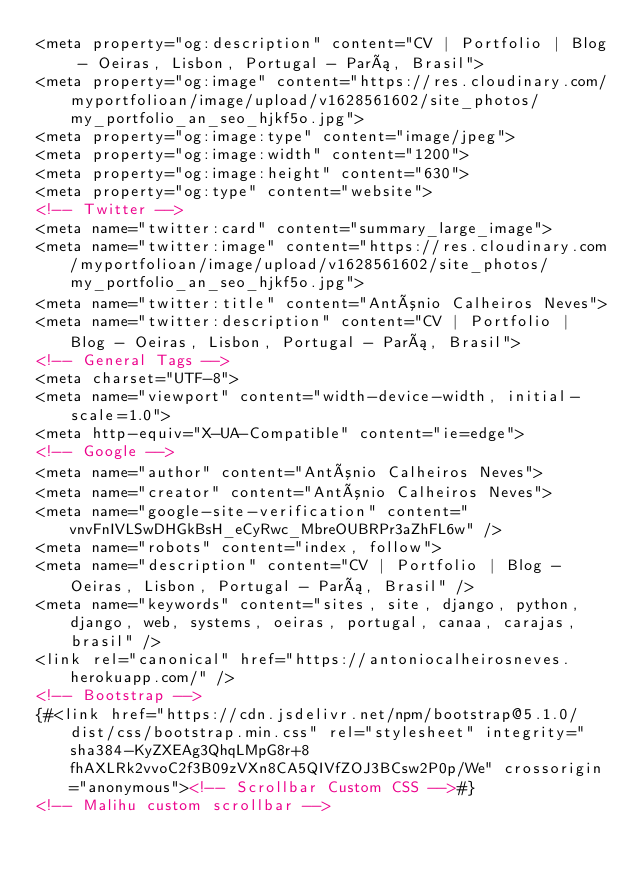Convert code to text. <code><loc_0><loc_0><loc_500><loc_500><_HTML_><meta property="og:description" content="CV | Portfolio | Blog - Oeiras, Lisbon, Portugal - Pará, Brasil">
<meta property="og:image" content="https://res.cloudinary.com/myportfolioan/image/upload/v1628561602/site_photos/my_portfolio_an_seo_hjkf5o.jpg">
<meta property="og:image:type" content="image/jpeg">
<meta property="og:image:width" content="1200">
<meta property="og:image:height" content="630">
<meta property="og:type" content="website">
<!-- Twitter -->
<meta name="twitter:card" content="summary_large_image">
<meta name="twitter:image" content="https://res.cloudinary.com/myportfolioan/image/upload/v1628561602/site_photos/my_portfolio_an_seo_hjkf5o.jpg">
<meta name="twitter:title" content="António Calheiros Neves">
<meta name="twitter:description" content="CV | Portfolio | Blog - Oeiras, Lisbon, Portugal - Pará, Brasil">
<!-- General Tags -->
<meta charset="UTF-8">
<meta name="viewport" content="width-device-width, initial-scale=1.0">
<meta http-equiv="X-UA-Compatible" content="ie=edge">
<!-- Google -->
<meta name="author" content="António Calheiros Neves">
<meta name="creator" content="António Calheiros Neves">
<meta name="google-site-verification" content="vnvFnIVLSwDHGkBsH_eCyRwc_MbreOUBRPr3aZhFL6w" />
<meta name="robots" content="index, follow">
<meta name="description" content="CV | Portfolio | Blog - Oeiras, Lisbon, Portugal - Pará, Brasil" />
<meta name="keywords" content="sites, site, django, python, django, web, systems, oeiras, portugal, canaa, carajas, brasil" />
<link rel="canonical" href="https://antoniocalheirosneves.herokuapp.com/" />
<!-- Bootstrap -->
{#<link href="https://cdn.jsdelivr.net/npm/bootstrap@5.1.0/dist/css/bootstrap.min.css" rel="stylesheet" integrity="sha384-KyZXEAg3QhqLMpG8r+8fhAXLRk2vvoC2f3B09zVXn8CA5QIVfZOJ3BCsw2P0p/We" crossorigin="anonymous"><!-- Scrollbar Custom CSS -->#}
<!-- Malihu custom scrollbar --></code> 